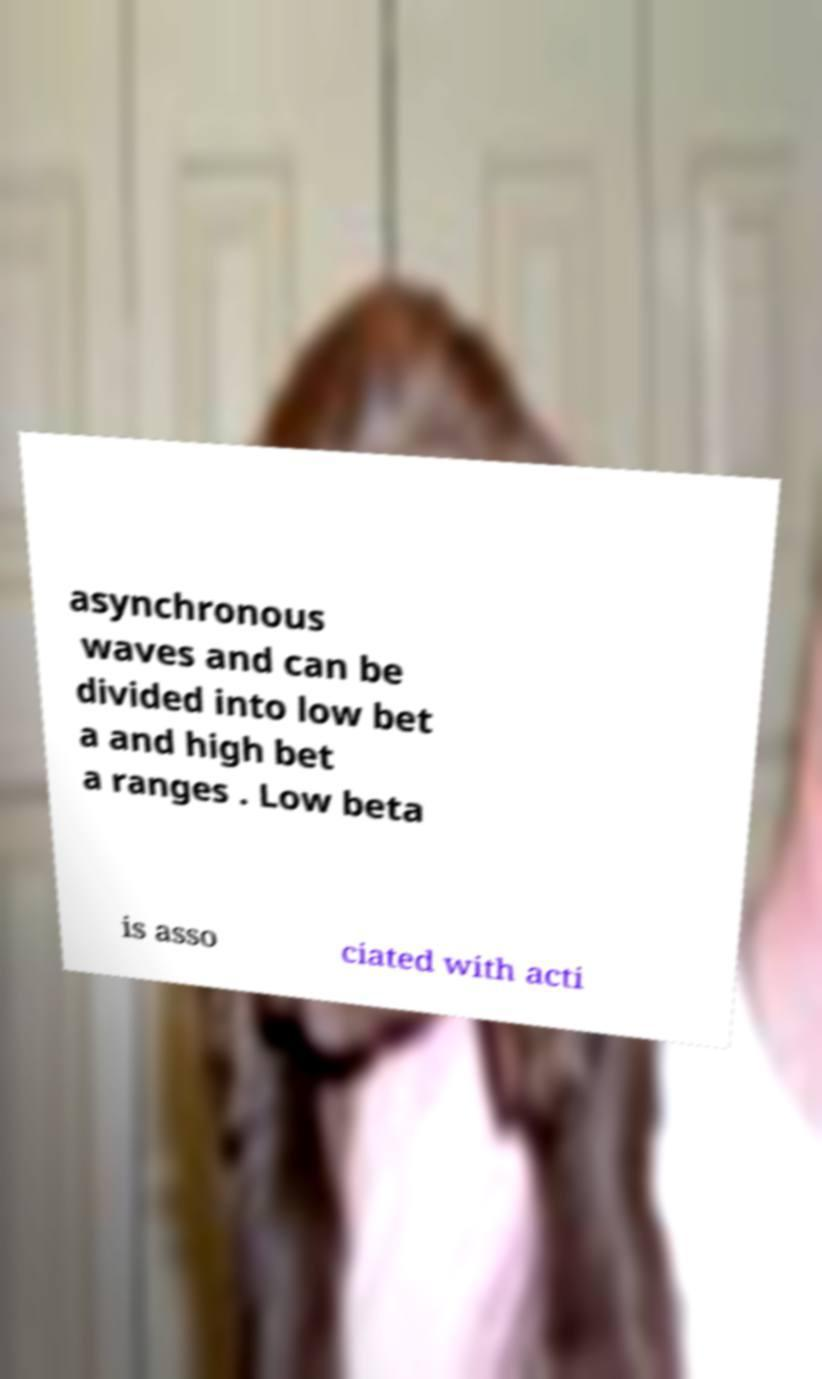For documentation purposes, I need the text within this image transcribed. Could you provide that? asynchronous waves and can be divided into low bet a and high bet a ranges . Low beta is asso ciated with acti 